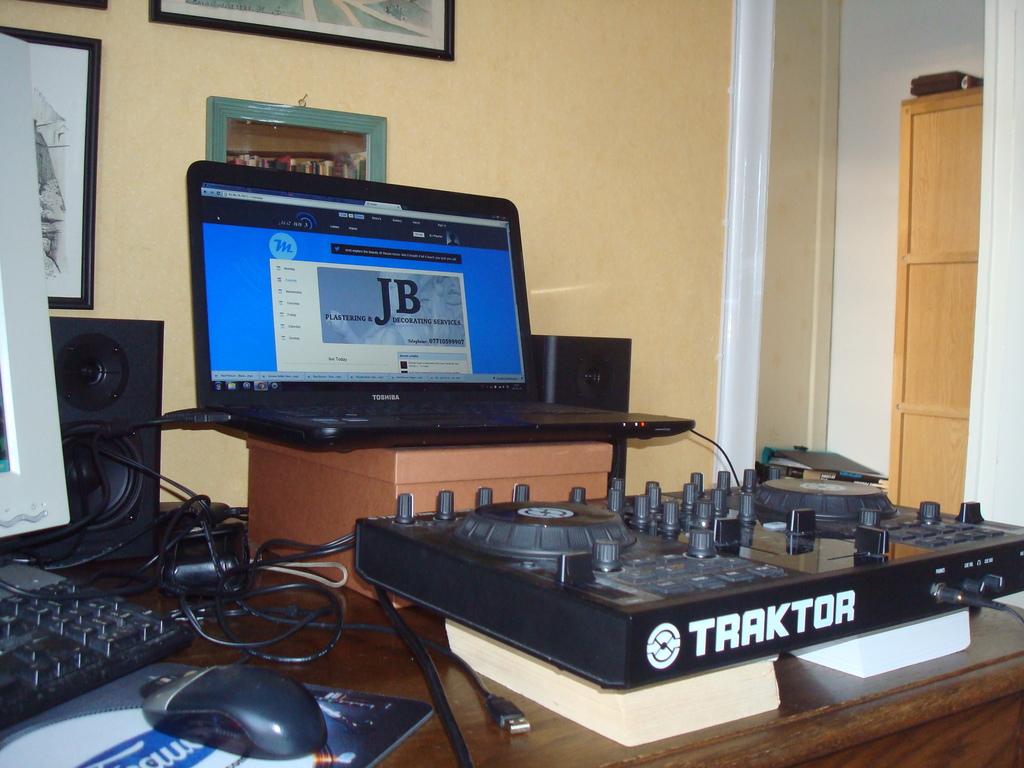What brand is this?
Offer a very short reply. Traktor. What letters are mentioned on the laptop's screen?
Ensure brevity in your answer.  Jb. 